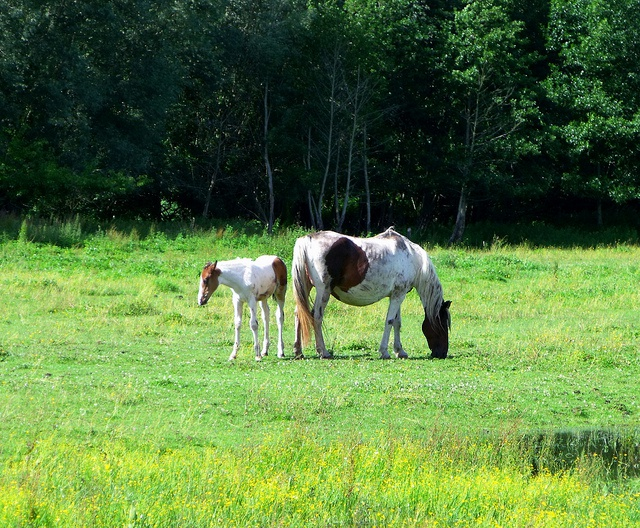Describe the objects in this image and their specific colors. I can see horse in teal, gray, black, white, and darkgray tones and horse in teal, white, darkgray, and gray tones in this image. 